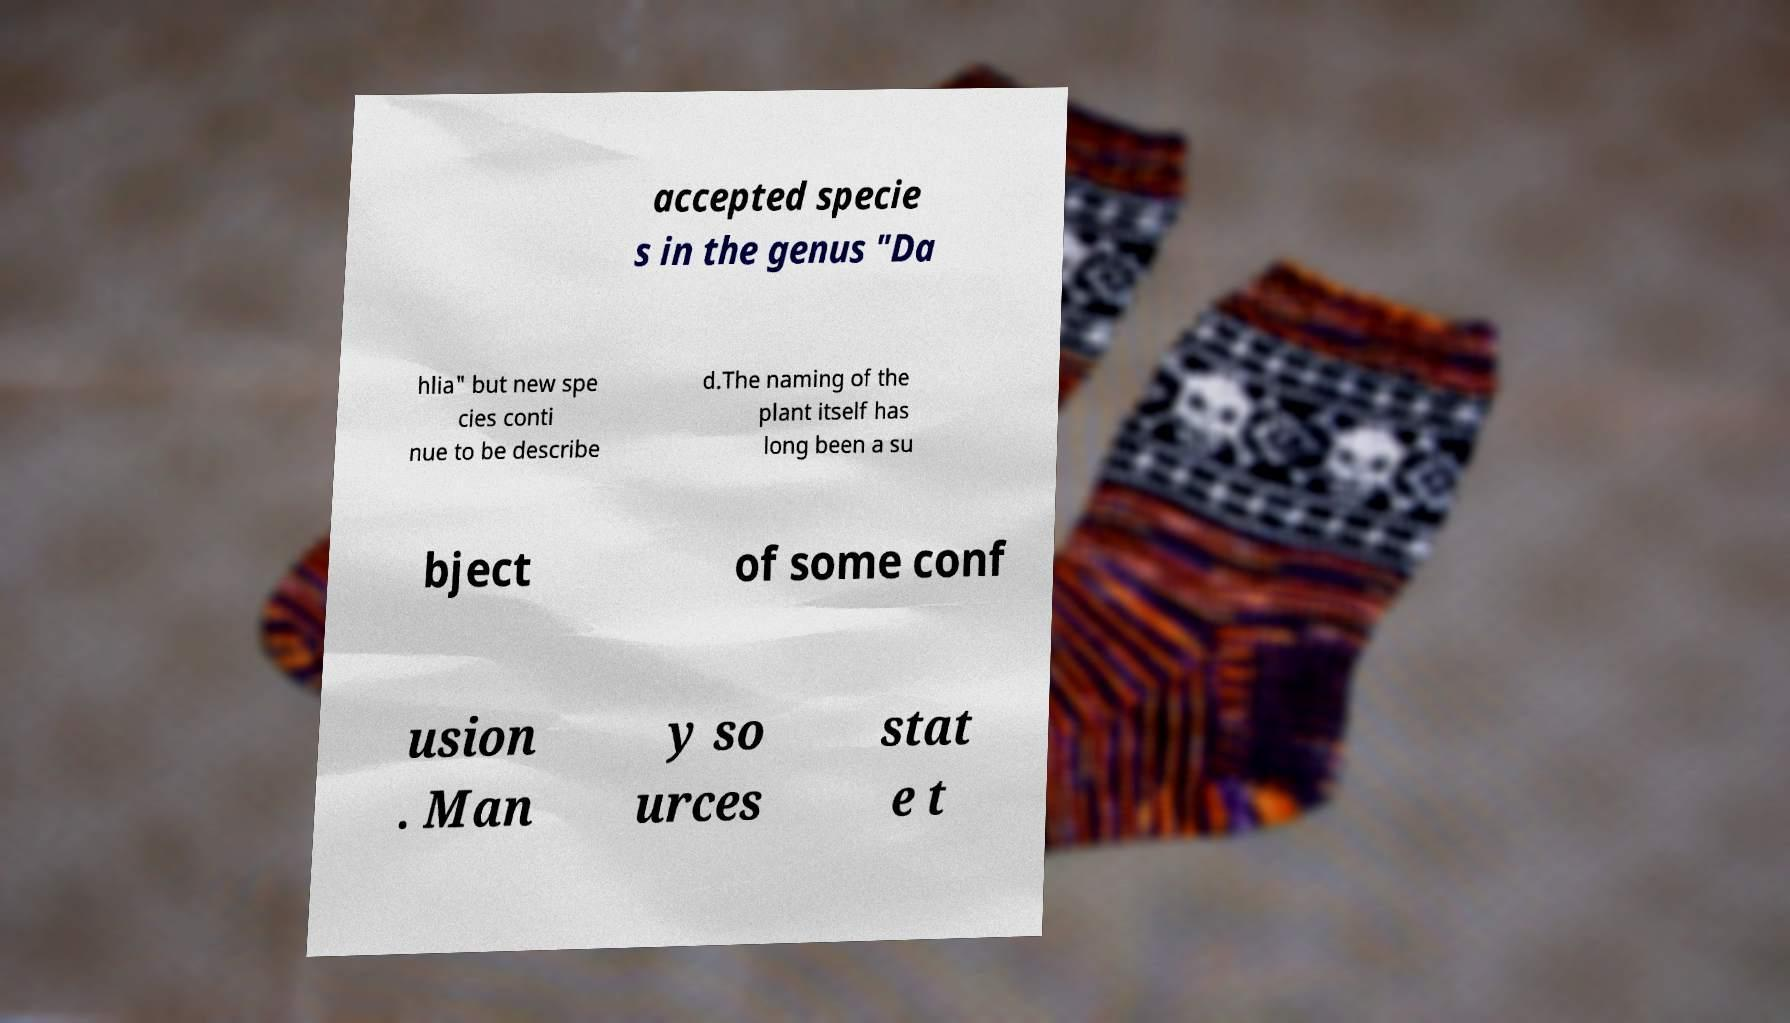Can you accurately transcribe the text from the provided image for me? accepted specie s in the genus "Da hlia" but new spe cies conti nue to be describe d.The naming of the plant itself has long been a su bject of some conf usion . Man y so urces stat e t 